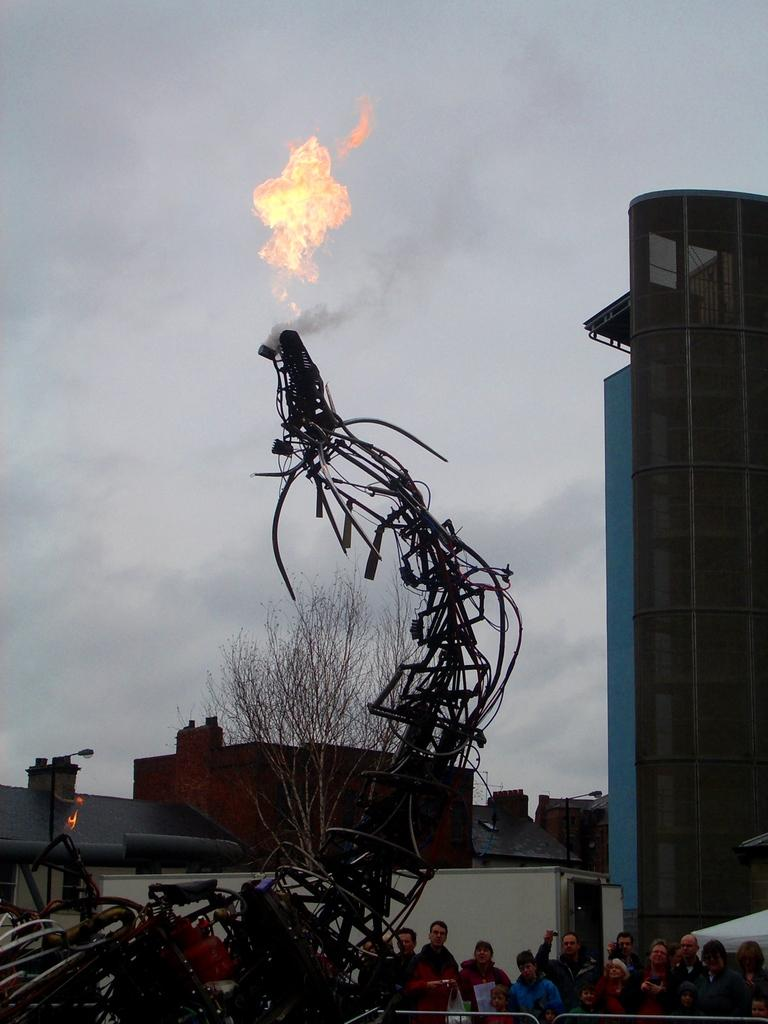What type of structure is present in the image? There is a building in the image. Are there any living beings in the image? Yes, there are people standing in the image. What other natural element is visible in the image? There is a tree in the image. What can be seen in the sky in the image? The sky is visible in the image, and it is cloudy. Can you see any ducks swimming in the image? There are no ducks present in the image. What type of horn is being played by the people in the image? There is no horn being played by the people in the image. 